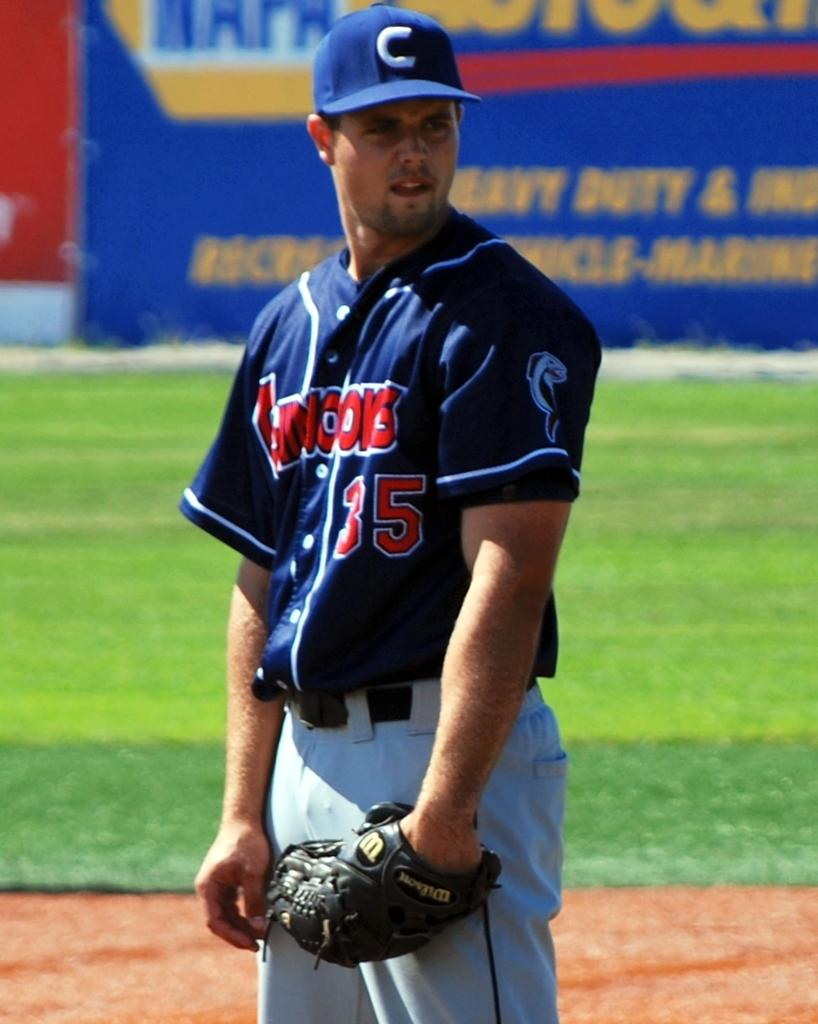<image>
Offer a succinct explanation of the picture presented. A Chinooks players stands ready with his Wilson glove on his hand. 